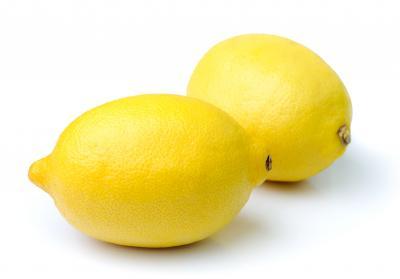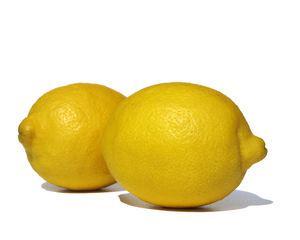The first image is the image on the left, the second image is the image on the right. For the images displayed, is the sentence "There is one half of a lemon in one of the images." factually correct? Answer yes or no. No. 